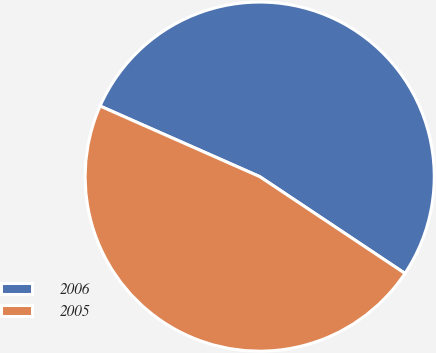<chart> <loc_0><loc_0><loc_500><loc_500><pie_chart><fcel>2006<fcel>2005<nl><fcel>52.73%<fcel>47.27%<nl></chart> 